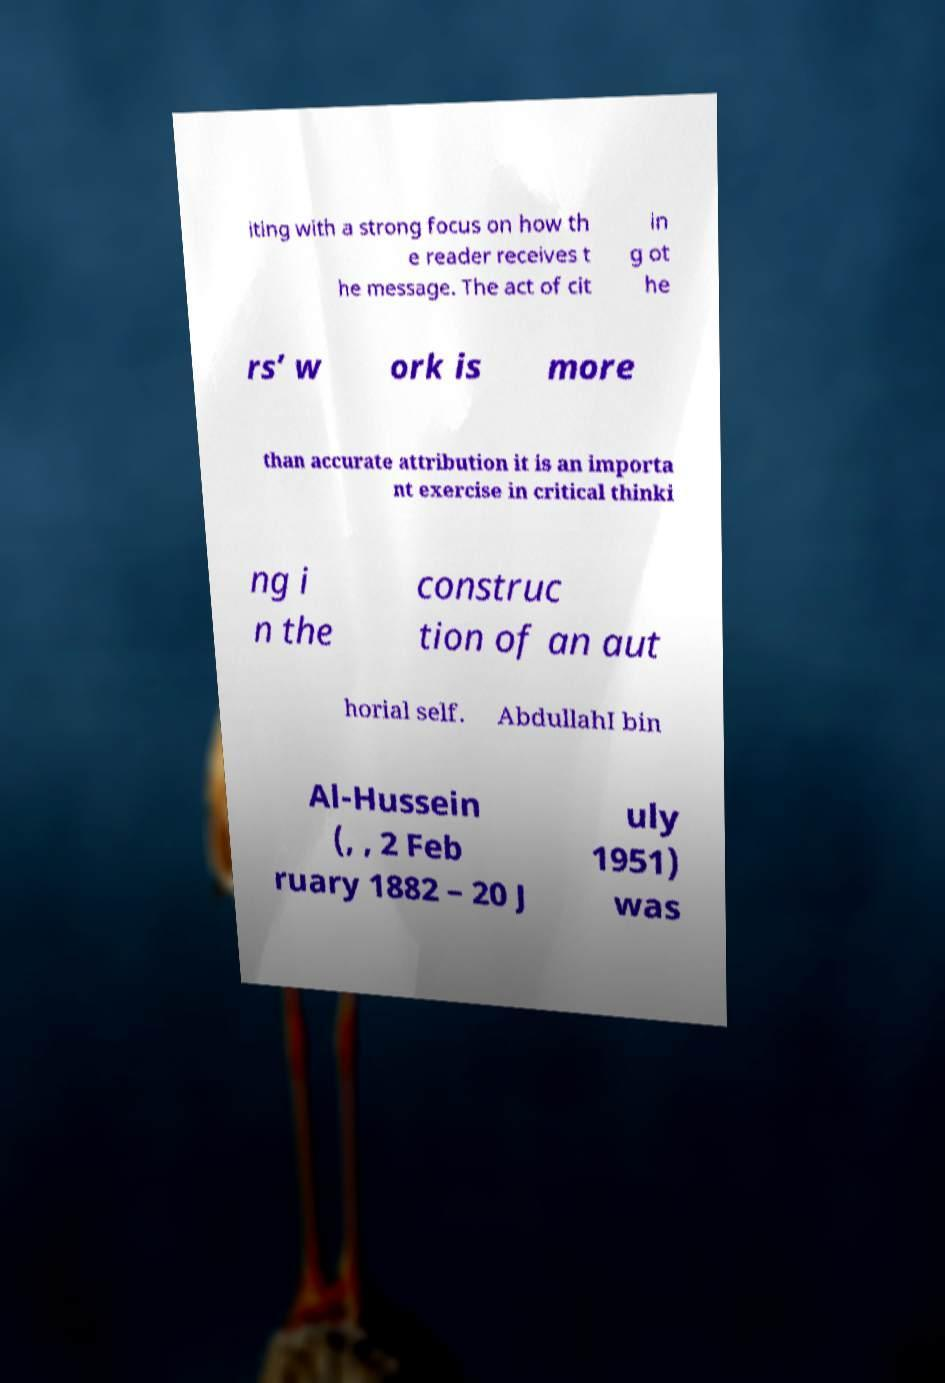Can you read and provide the text displayed in the image?This photo seems to have some interesting text. Can you extract and type it out for me? iting with a strong focus on how th e reader receives t he message. The act of cit in g ot he rs’ w ork is more than accurate attribution it is an importa nt exercise in critical thinki ng i n the construc tion of an aut horial self. AbdullahI bin Al-Hussein (, , 2 Feb ruary 1882 – 20 J uly 1951) was 